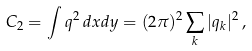Convert formula to latex. <formula><loc_0><loc_0><loc_500><loc_500>C _ { 2 } = \int q ^ { 2 } \, d x d y = ( 2 \pi ) ^ { 2 } \sum _ { k } | q _ { k } | ^ { 2 } \, ,</formula> 